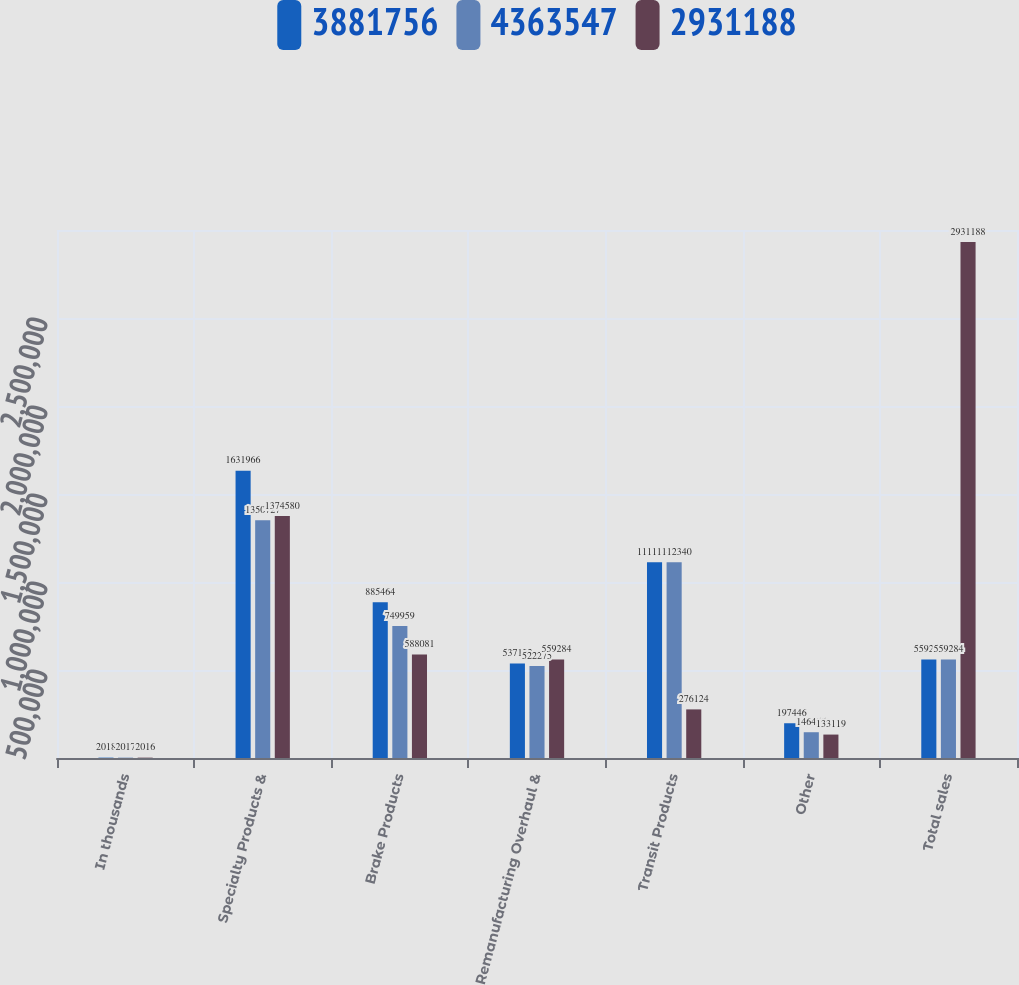Convert chart. <chart><loc_0><loc_0><loc_500><loc_500><stacked_bar_chart><ecel><fcel>In thousands<fcel>Specialty Products &<fcel>Brake Products<fcel>Remanufacturing Overhaul &<fcel>Transit Products<fcel>Other<fcel>Total sales<nl><fcel>3.88176e+06<fcel>2018<fcel>1.63197e+06<fcel>885464<fcel>537122<fcel>1.11155e+06<fcel>197446<fcel>559284<nl><fcel>4.36355e+06<fcel>2017<fcel>1.35073e+06<fcel>749959<fcel>522275<fcel>1.11234e+06<fcel>146455<fcel>559284<nl><fcel>2.93119e+06<fcel>2016<fcel>1.37458e+06<fcel>588081<fcel>559284<fcel>276124<fcel>133119<fcel>2.93119e+06<nl></chart> 